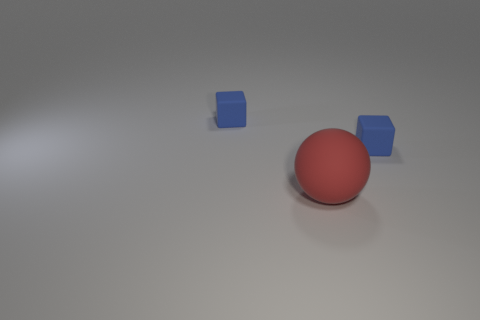What number of matte things are big red things or blue cubes?
Offer a very short reply. 3. What is the cube that is to the left of the red matte sphere made of?
Your answer should be very brief. Rubber. What number of things are tiny matte cubes or blue objects that are on the right side of the red matte sphere?
Offer a terse response. 2. What number of other big objects are the same color as the large thing?
Keep it short and to the point. 0. Is the tiny object on the left side of the rubber ball made of the same material as the large thing?
Your answer should be very brief. Yes. The big object has what shape?
Provide a succinct answer. Sphere. How many yellow objects are either tiny matte blocks or large matte objects?
Keep it short and to the point. 0. There is a blue thing that is to the left of the large red matte sphere; does it have the same shape as the large thing?
Provide a short and direct response. No. Are any big brown matte balls visible?
Your answer should be compact. No. Is there any other thing that has the same shape as the red rubber object?
Provide a succinct answer. No. 